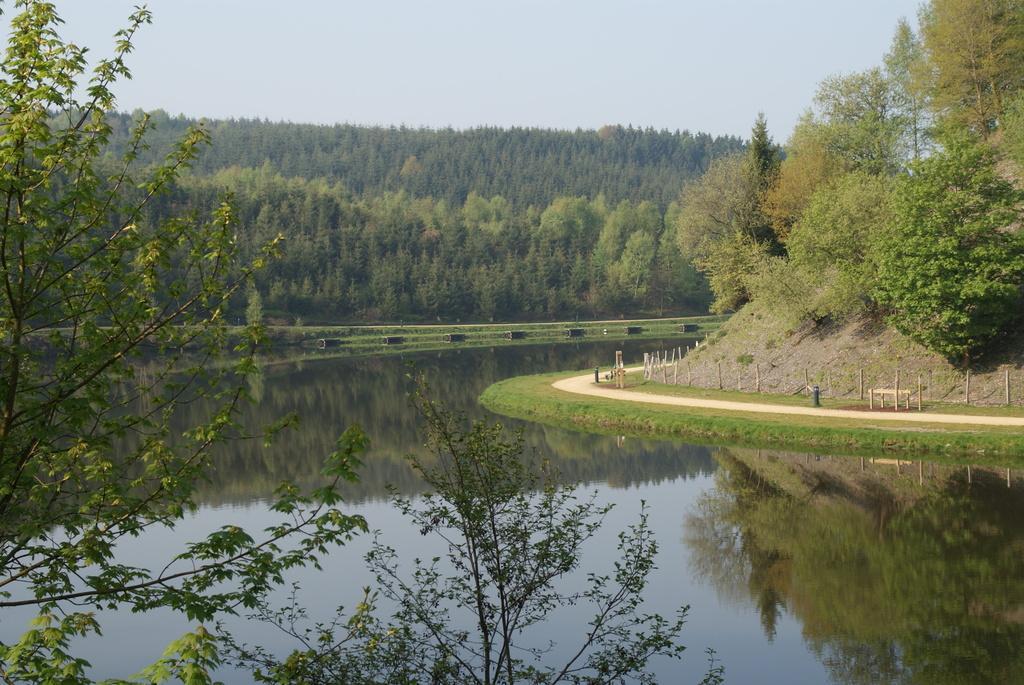Can you describe this image briefly? In this picture we can see many trees. At the bottom we can see the water. On the right we can see the fencing, bench, poles and other objects. At the top there is a sky. 